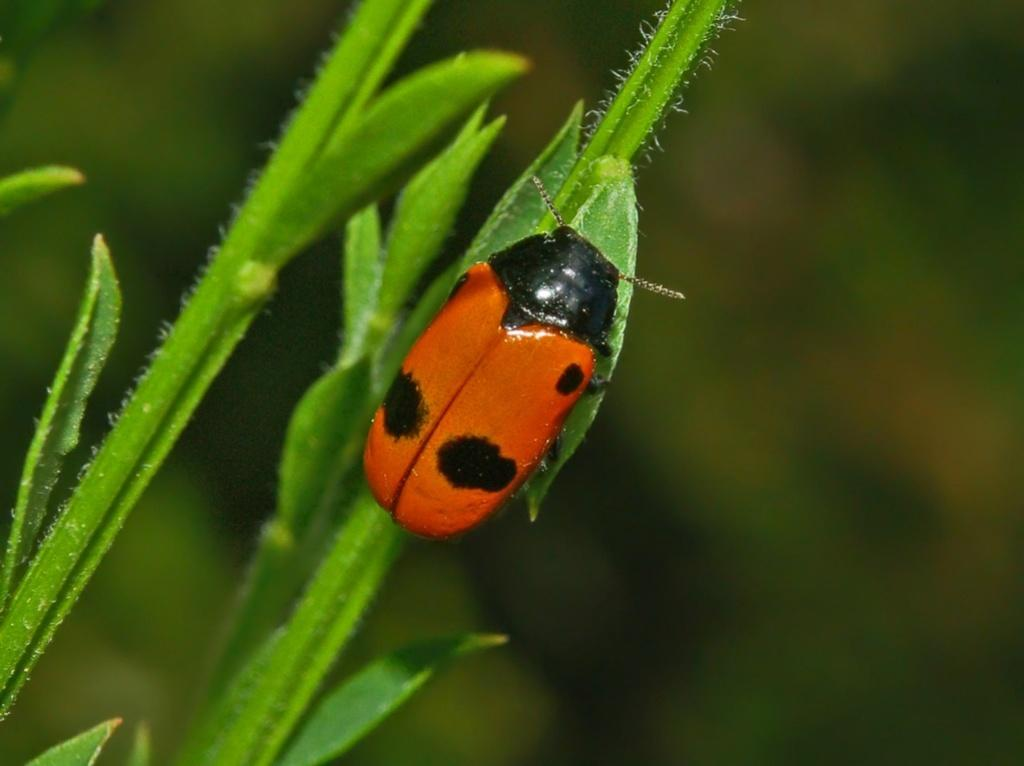What type of vegetation can be seen on the left side of the image? There are leaves on the left side of the image. Is there anything else present on the leaves? Yes, there is a bug on one of the leaves. How would you describe the background of the image? The background of the image is blurry. Can you tell me how many grains of rice are visible in the image? There is no rice present in the image; it features leaves and a bug. Is there a girl walking in the image? There is no girl or any indication of walking in the image. 